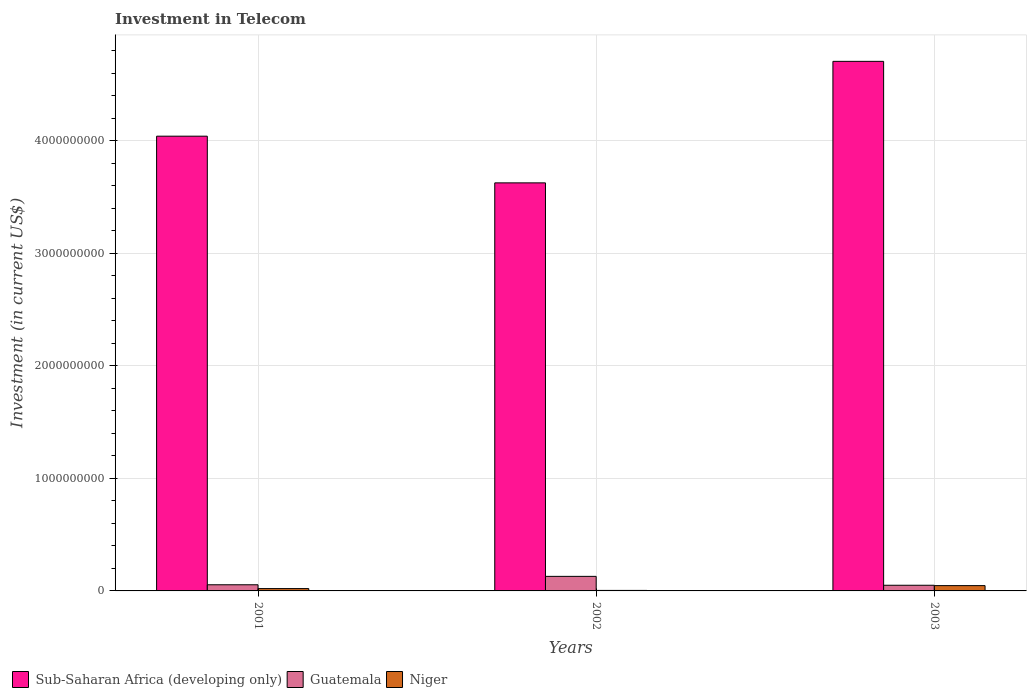How many different coloured bars are there?
Provide a short and direct response. 3. How many bars are there on the 2nd tick from the right?
Provide a short and direct response. 3. What is the label of the 2nd group of bars from the left?
Keep it short and to the point. 2002. In how many cases, is the number of bars for a given year not equal to the number of legend labels?
Keep it short and to the point. 0. What is the amount invested in telecom in Sub-Saharan Africa (developing only) in 2002?
Offer a very short reply. 3.63e+09. Across all years, what is the maximum amount invested in telecom in Guatemala?
Keep it short and to the point. 1.29e+08. Across all years, what is the minimum amount invested in telecom in Niger?
Your response must be concise. 4.50e+06. What is the total amount invested in telecom in Niger in the graph?
Keep it short and to the point. 7.24e+07. What is the difference between the amount invested in telecom in Guatemala in 2002 and that in 2003?
Provide a succinct answer. 7.91e+07. What is the difference between the amount invested in telecom in Niger in 2003 and the amount invested in telecom in Sub-Saharan Africa (developing only) in 2002?
Ensure brevity in your answer.  -3.58e+09. What is the average amount invested in telecom in Sub-Saharan Africa (developing only) per year?
Offer a terse response. 4.13e+09. In the year 2003, what is the difference between the amount invested in telecom in Niger and amount invested in telecom in Guatemala?
Give a very brief answer. -3.10e+06. What is the ratio of the amount invested in telecom in Niger in 2002 to that in 2003?
Your answer should be very brief. 0.1. Is the amount invested in telecom in Guatemala in 2001 less than that in 2003?
Make the answer very short. No. What is the difference between the highest and the second highest amount invested in telecom in Guatemala?
Offer a very short reply. 7.47e+07. What is the difference between the highest and the lowest amount invested in telecom in Sub-Saharan Africa (developing only)?
Give a very brief answer. 1.08e+09. In how many years, is the amount invested in telecom in Guatemala greater than the average amount invested in telecom in Guatemala taken over all years?
Your answer should be compact. 1. What does the 1st bar from the left in 2001 represents?
Offer a very short reply. Sub-Saharan Africa (developing only). What does the 2nd bar from the right in 2003 represents?
Offer a terse response. Guatemala. How many years are there in the graph?
Give a very brief answer. 3. Does the graph contain grids?
Provide a short and direct response. Yes. What is the title of the graph?
Offer a terse response. Investment in Telecom. What is the label or title of the Y-axis?
Keep it short and to the point. Investment (in current US$). What is the Investment (in current US$) of Sub-Saharan Africa (developing only) in 2001?
Your response must be concise. 4.04e+09. What is the Investment (in current US$) in Guatemala in 2001?
Your answer should be compact. 5.47e+07. What is the Investment (in current US$) in Niger in 2001?
Give a very brief answer. 2.07e+07. What is the Investment (in current US$) in Sub-Saharan Africa (developing only) in 2002?
Give a very brief answer. 3.63e+09. What is the Investment (in current US$) of Guatemala in 2002?
Keep it short and to the point. 1.29e+08. What is the Investment (in current US$) in Niger in 2002?
Give a very brief answer. 4.50e+06. What is the Investment (in current US$) of Sub-Saharan Africa (developing only) in 2003?
Your response must be concise. 4.71e+09. What is the Investment (in current US$) of Guatemala in 2003?
Ensure brevity in your answer.  5.03e+07. What is the Investment (in current US$) in Niger in 2003?
Your answer should be compact. 4.72e+07. Across all years, what is the maximum Investment (in current US$) of Sub-Saharan Africa (developing only)?
Make the answer very short. 4.71e+09. Across all years, what is the maximum Investment (in current US$) in Guatemala?
Offer a terse response. 1.29e+08. Across all years, what is the maximum Investment (in current US$) of Niger?
Ensure brevity in your answer.  4.72e+07. Across all years, what is the minimum Investment (in current US$) of Sub-Saharan Africa (developing only)?
Give a very brief answer. 3.63e+09. Across all years, what is the minimum Investment (in current US$) in Guatemala?
Give a very brief answer. 5.03e+07. Across all years, what is the minimum Investment (in current US$) of Niger?
Make the answer very short. 4.50e+06. What is the total Investment (in current US$) of Sub-Saharan Africa (developing only) in the graph?
Provide a succinct answer. 1.24e+1. What is the total Investment (in current US$) of Guatemala in the graph?
Provide a succinct answer. 2.34e+08. What is the total Investment (in current US$) of Niger in the graph?
Your answer should be compact. 7.24e+07. What is the difference between the Investment (in current US$) of Sub-Saharan Africa (developing only) in 2001 and that in 2002?
Make the answer very short. 4.15e+08. What is the difference between the Investment (in current US$) of Guatemala in 2001 and that in 2002?
Ensure brevity in your answer.  -7.47e+07. What is the difference between the Investment (in current US$) in Niger in 2001 and that in 2002?
Keep it short and to the point. 1.62e+07. What is the difference between the Investment (in current US$) in Sub-Saharan Africa (developing only) in 2001 and that in 2003?
Give a very brief answer. -6.65e+08. What is the difference between the Investment (in current US$) in Guatemala in 2001 and that in 2003?
Keep it short and to the point. 4.40e+06. What is the difference between the Investment (in current US$) of Niger in 2001 and that in 2003?
Your answer should be very brief. -2.65e+07. What is the difference between the Investment (in current US$) in Sub-Saharan Africa (developing only) in 2002 and that in 2003?
Your answer should be very brief. -1.08e+09. What is the difference between the Investment (in current US$) in Guatemala in 2002 and that in 2003?
Make the answer very short. 7.91e+07. What is the difference between the Investment (in current US$) in Niger in 2002 and that in 2003?
Provide a short and direct response. -4.27e+07. What is the difference between the Investment (in current US$) in Sub-Saharan Africa (developing only) in 2001 and the Investment (in current US$) in Guatemala in 2002?
Your answer should be compact. 3.91e+09. What is the difference between the Investment (in current US$) in Sub-Saharan Africa (developing only) in 2001 and the Investment (in current US$) in Niger in 2002?
Your answer should be compact. 4.04e+09. What is the difference between the Investment (in current US$) of Guatemala in 2001 and the Investment (in current US$) of Niger in 2002?
Provide a short and direct response. 5.02e+07. What is the difference between the Investment (in current US$) of Sub-Saharan Africa (developing only) in 2001 and the Investment (in current US$) of Guatemala in 2003?
Give a very brief answer. 3.99e+09. What is the difference between the Investment (in current US$) of Sub-Saharan Africa (developing only) in 2001 and the Investment (in current US$) of Niger in 2003?
Make the answer very short. 4.00e+09. What is the difference between the Investment (in current US$) in Guatemala in 2001 and the Investment (in current US$) in Niger in 2003?
Offer a terse response. 7.50e+06. What is the difference between the Investment (in current US$) of Sub-Saharan Africa (developing only) in 2002 and the Investment (in current US$) of Guatemala in 2003?
Offer a very short reply. 3.58e+09. What is the difference between the Investment (in current US$) of Sub-Saharan Africa (developing only) in 2002 and the Investment (in current US$) of Niger in 2003?
Keep it short and to the point. 3.58e+09. What is the difference between the Investment (in current US$) of Guatemala in 2002 and the Investment (in current US$) of Niger in 2003?
Keep it short and to the point. 8.22e+07. What is the average Investment (in current US$) of Sub-Saharan Africa (developing only) per year?
Keep it short and to the point. 4.13e+09. What is the average Investment (in current US$) in Guatemala per year?
Give a very brief answer. 7.81e+07. What is the average Investment (in current US$) of Niger per year?
Give a very brief answer. 2.41e+07. In the year 2001, what is the difference between the Investment (in current US$) in Sub-Saharan Africa (developing only) and Investment (in current US$) in Guatemala?
Make the answer very short. 3.99e+09. In the year 2001, what is the difference between the Investment (in current US$) in Sub-Saharan Africa (developing only) and Investment (in current US$) in Niger?
Give a very brief answer. 4.02e+09. In the year 2001, what is the difference between the Investment (in current US$) in Guatemala and Investment (in current US$) in Niger?
Give a very brief answer. 3.40e+07. In the year 2002, what is the difference between the Investment (in current US$) of Sub-Saharan Africa (developing only) and Investment (in current US$) of Guatemala?
Ensure brevity in your answer.  3.50e+09. In the year 2002, what is the difference between the Investment (in current US$) in Sub-Saharan Africa (developing only) and Investment (in current US$) in Niger?
Your answer should be compact. 3.62e+09. In the year 2002, what is the difference between the Investment (in current US$) in Guatemala and Investment (in current US$) in Niger?
Offer a very short reply. 1.25e+08. In the year 2003, what is the difference between the Investment (in current US$) in Sub-Saharan Africa (developing only) and Investment (in current US$) in Guatemala?
Offer a very short reply. 4.66e+09. In the year 2003, what is the difference between the Investment (in current US$) in Sub-Saharan Africa (developing only) and Investment (in current US$) in Niger?
Offer a terse response. 4.66e+09. In the year 2003, what is the difference between the Investment (in current US$) of Guatemala and Investment (in current US$) of Niger?
Keep it short and to the point. 3.10e+06. What is the ratio of the Investment (in current US$) of Sub-Saharan Africa (developing only) in 2001 to that in 2002?
Offer a very short reply. 1.11. What is the ratio of the Investment (in current US$) in Guatemala in 2001 to that in 2002?
Make the answer very short. 0.42. What is the ratio of the Investment (in current US$) of Niger in 2001 to that in 2002?
Provide a succinct answer. 4.6. What is the ratio of the Investment (in current US$) of Sub-Saharan Africa (developing only) in 2001 to that in 2003?
Ensure brevity in your answer.  0.86. What is the ratio of the Investment (in current US$) of Guatemala in 2001 to that in 2003?
Your answer should be compact. 1.09. What is the ratio of the Investment (in current US$) in Niger in 2001 to that in 2003?
Your answer should be compact. 0.44. What is the ratio of the Investment (in current US$) in Sub-Saharan Africa (developing only) in 2002 to that in 2003?
Provide a short and direct response. 0.77. What is the ratio of the Investment (in current US$) of Guatemala in 2002 to that in 2003?
Offer a very short reply. 2.57. What is the ratio of the Investment (in current US$) in Niger in 2002 to that in 2003?
Your answer should be very brief. 0.1. What is the difference between the highest and the second highest Investment (in current US$) in Sub-Saharan Africa (developing only)?
Your response must be concise. 6.65e+08. What is the difference between the highest and the second highest Investment (in current US$) of Guatemala?
Your response must be concise. 7.47e+07. What is the difference between the highest and the second highest Investment (in current US$) in Niger?
Your response must be concise. 2.65e+07. What is the difference between the highest and the lowest Investment (in current US$) of Sub-Saharan Africa (developing only)?
Make the answer very short. 1.08e+09. What is the difference between the highest and the lowest Investment (in current US$) of Guatemala?
Provide a short and direct response. 7.91e+07. What is the difference between the highest and the lowest Investment (in current US$) in Niger?
Make the answer very short. 4.27e+07. 